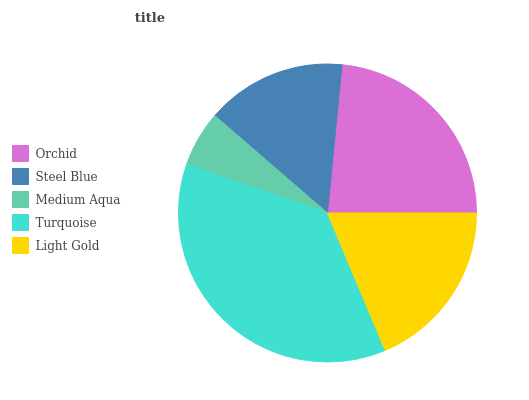Is Medium Aqua the minimum?
Answer yes or no. Yes. Is Turquoise the maximum?
Answer yes or no. Yes. Is Steel Blue the minimum?
Answer yes or no. No. Is Steel Blue the maximum?
Answer yes or no. No. Is Orchid greater than Steel Blue?
Answer yes or no. Yes. Is Steel Blue less than Orchid?
Answer yes or no. Yes. Is Steel Blue greater than Orchid?
Answer yes or no. No. Is Orchid less than Steel Blue?
Answer yes or no. No. Is Light Gold the high median?
Answer yes or no. Yes. Is Light Gold the low median?
Answer yes or no. Yes. Is Turquoise the high median?
Answer yes or no. No. Is Medium Aqua the low median?
Answer yes or no. No. 